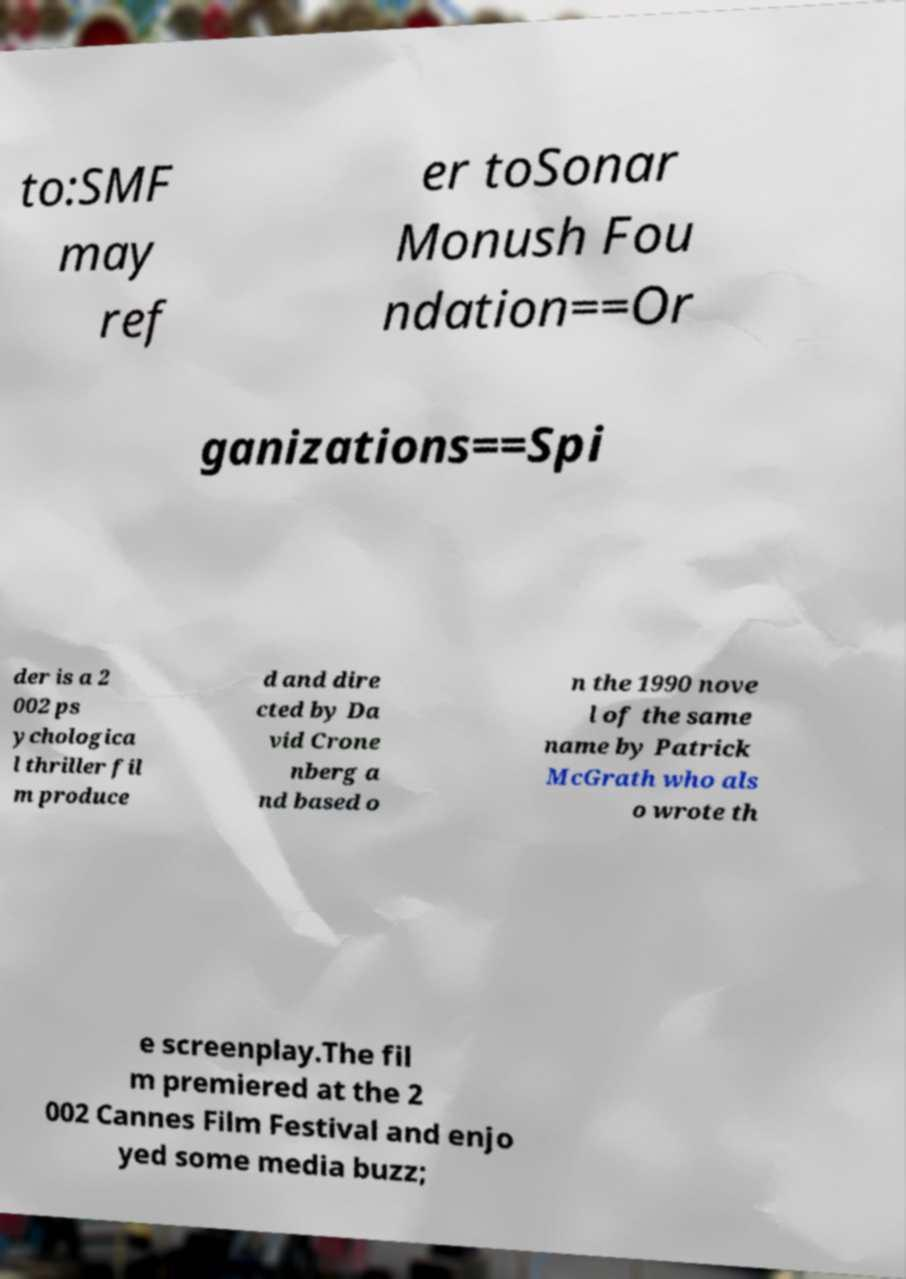Can you accurately transcribe the text from the provided image for me? to:SMF may ref er toSonar Monush Fou ndation==Or ganizations==Spi der is a 2 002 ps ychologica l thriller fil m produce d and dire cted by Da vid Crone nberg a nd based o n the 1990 nove l of the same name by Patrick McGrath who als o wrote th e screenplay.The fil m premiered at the 2 002 Cannes Film Festival and enjo yed some media buzz; 